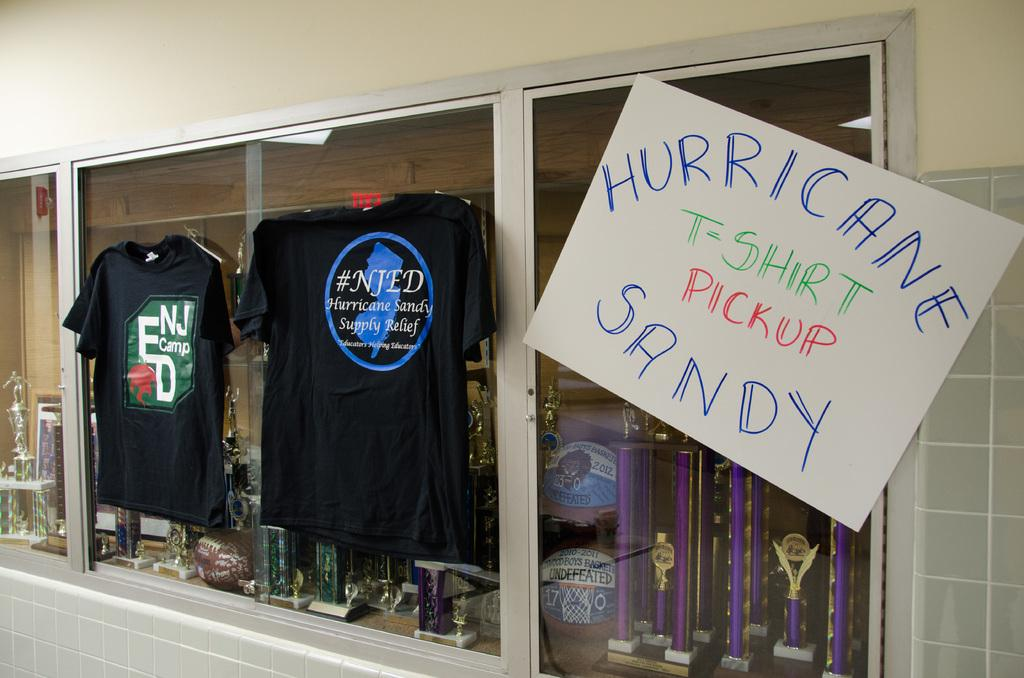<image>
Offer a succinct explanation of the picture presented. a hurricane t shirt pickup sign that is outside 